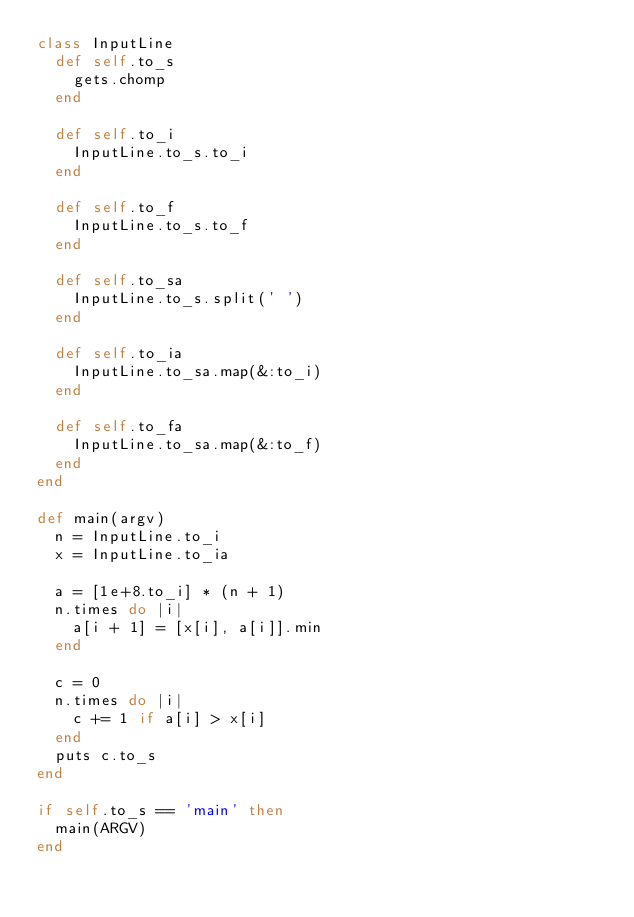Convert code to text. <code><loc_0><loc_0><loc_500><loc_500><_Ruby_>class InputLine
  def self.to_s
    gets.chomp
  end

  def self.to_i
    InputLine.to_s.to_i
  end
  
  def self.to_f
    InputLine.to_s.to_f
  end

  def self.to_sa
    InputLine.to_s.split(' ')
  end

  def self.to_ia
    InputLine.to_sa.map(&:to_i)
  end
  
  def self.to_fa
    InputLine.to_sa.map(&:to_f)
  end
end

def main(argv)
  n = InputLine.to_i
  x = InputLine.to_ia

  a = [1e+8.to_i] * (n + 1)
  n.times do |i|
    a[i + 1] = [x[i], a[i]].min
  end
  
  c = 0
  n.times do |i|
    c += 1 if a[i] > x[i]
  end
  puts c.to_s
end

if self.to_s == 'main' then
  main(ARGV)
end</code> 